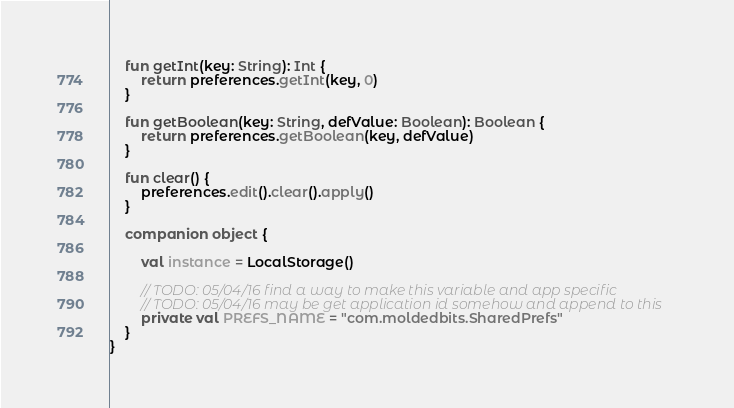<code> <loc_0><loc_0><loc_500><loc_500><_Kotlin_>    fun getInt(key: String): Int {
        return preferences.getInt(key, 0)
    }

    fun getBoolean(key: String, defValue: Boolean): Boolean {
        return preferences.getBoolean(key, defValue)
    }

    fun clear() {
        preferences.edit().clear().apply()
    }

    companion object {

        val instance = LocalStorage()

        // TODO: 05/04/16 find a way to make this variable and app specific
        // TODO: 05/04/16 may be get application id somehow and append to this
        private val PREFS_NAME = "com.moldedbits.SharedPrefs"
    }
}
</code> 